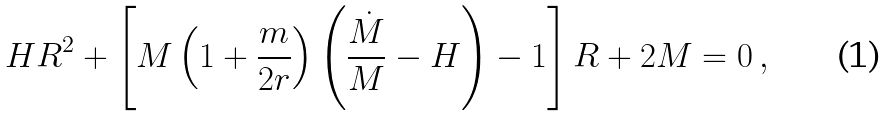Convert formula to latex. <formula><loc_0><loc_0><loc_500><loc_500>H R ^ { 2 } + \left [ M \left ( 1 + \frac { m } { 2 r } \right ) \left ( \frac { \dot { M } } { M } - H \right ) - 1 \right ] R + 2 M = 0 \, ,</formula> 